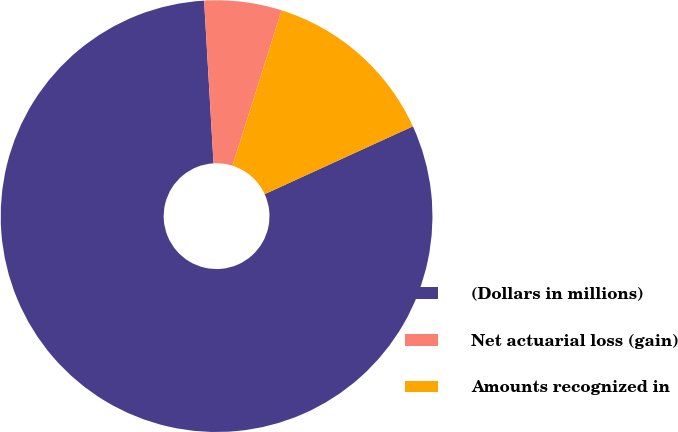<chart> <loc_0><loc_0><loc_500><loc_500><pie_chart><fcel>(Dollars in millions)<fcel>Net actuarial loss (gain)<fcel>Amounts recognized in<nl><fcel>80.91%<fcel>5.79%<fcel>13.3%<nl></chart> 